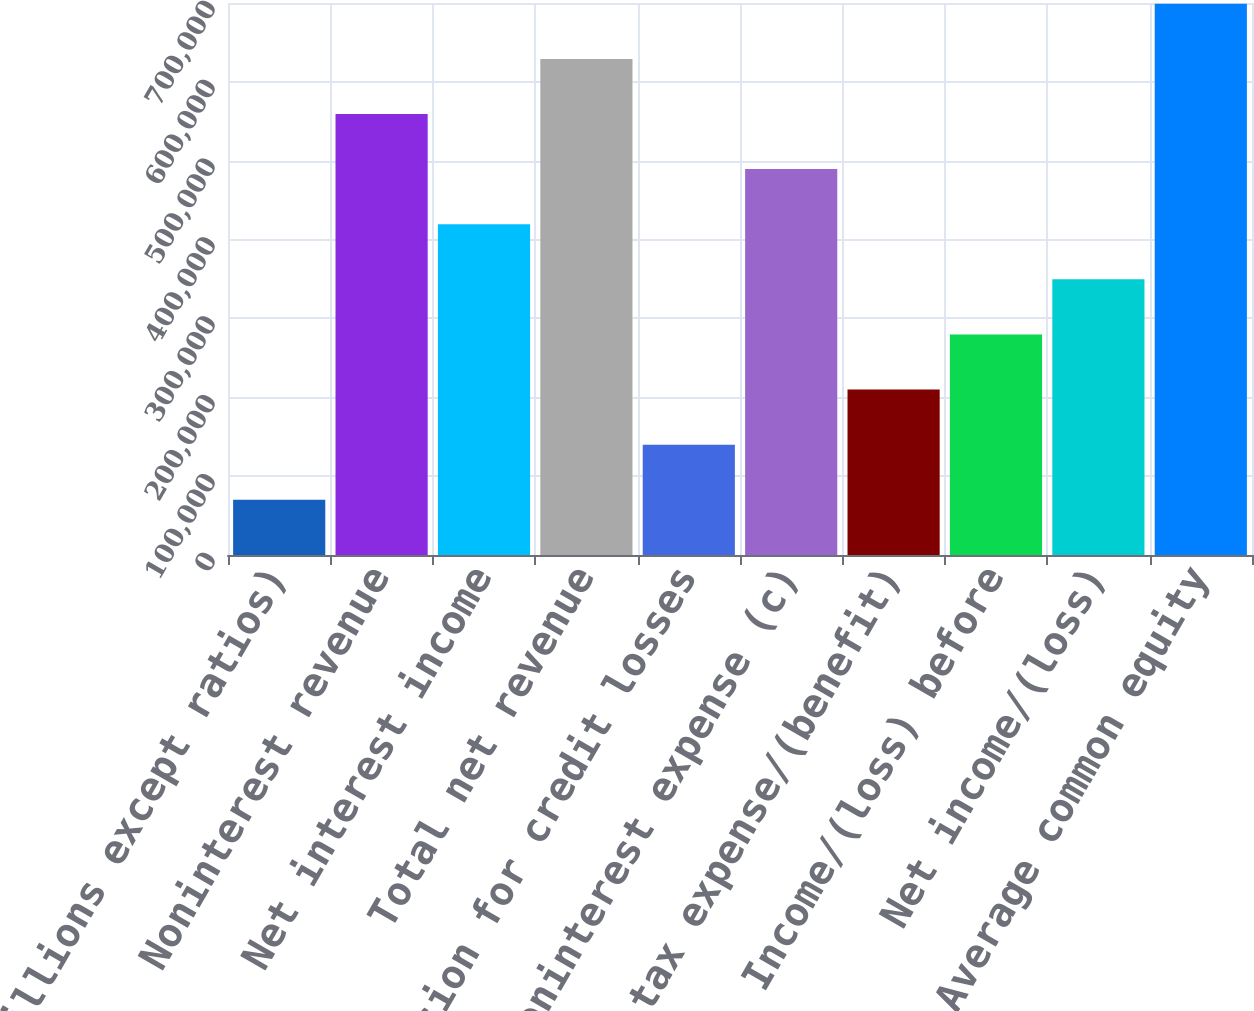Convert chart to OTSL. <chart><loc_0><loc_0><loc_500><loc_500><bar_chart><fcel>(in millions except ratios)<fcel>Noninterest revenue<fcel>Net interest income<fcel>Total net revenue<fcel>Provision for credit losses<fcel>Noninterest expense (c)<fcel>Income tax expense/(benefit)<fcel>Income/(loss) before<fcel>Net income/(loss)<fcel>Average common equity<nl><fcel>69953.4<fcel>559242<fcel>419445<fcel>629141<fcel>139852<fcel>489344<fcel>209750<fcel>279649<fcel>349547<fcel>699039<nl></chart> 